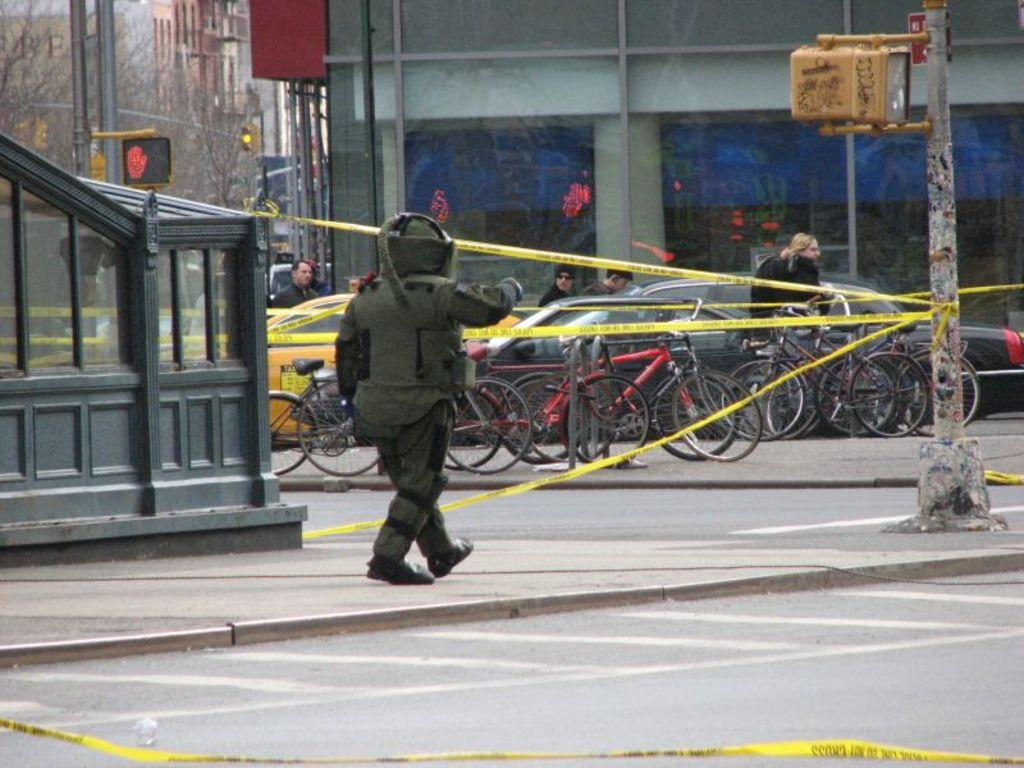What is the main action of the person in the image? There is a person walking in the image. What can be seen in the distance behind the person? There are vehicles, people sitting, buildings, and poles in the background of the image. What type of string is being used by the hen in the image? There is no hen present in the image, so there is no string being used. 